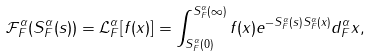Convert formula to latex. <formula><loc_0><loc_0><loc_500><loc_500>\mathcal { F } _ { F } ^ { \alpha } ( S _ { F } ^ { \alpha } ( s ) ) = \mathcal { L } _ { F } ^ { \alpha } [ f ( x ) ] = \int _ { S _ { F } ^ { \alpha } ( 0 ) } ^ { S _ { F } ^ { \alpha } ( \infty ) } f ( x ) e ^ { - S _ { F } ^ { \alpha } ( s ) S _ { F } ^ { \alpha } ( x ) } d _ { F } ^ { \alpha } x ,</formula> 